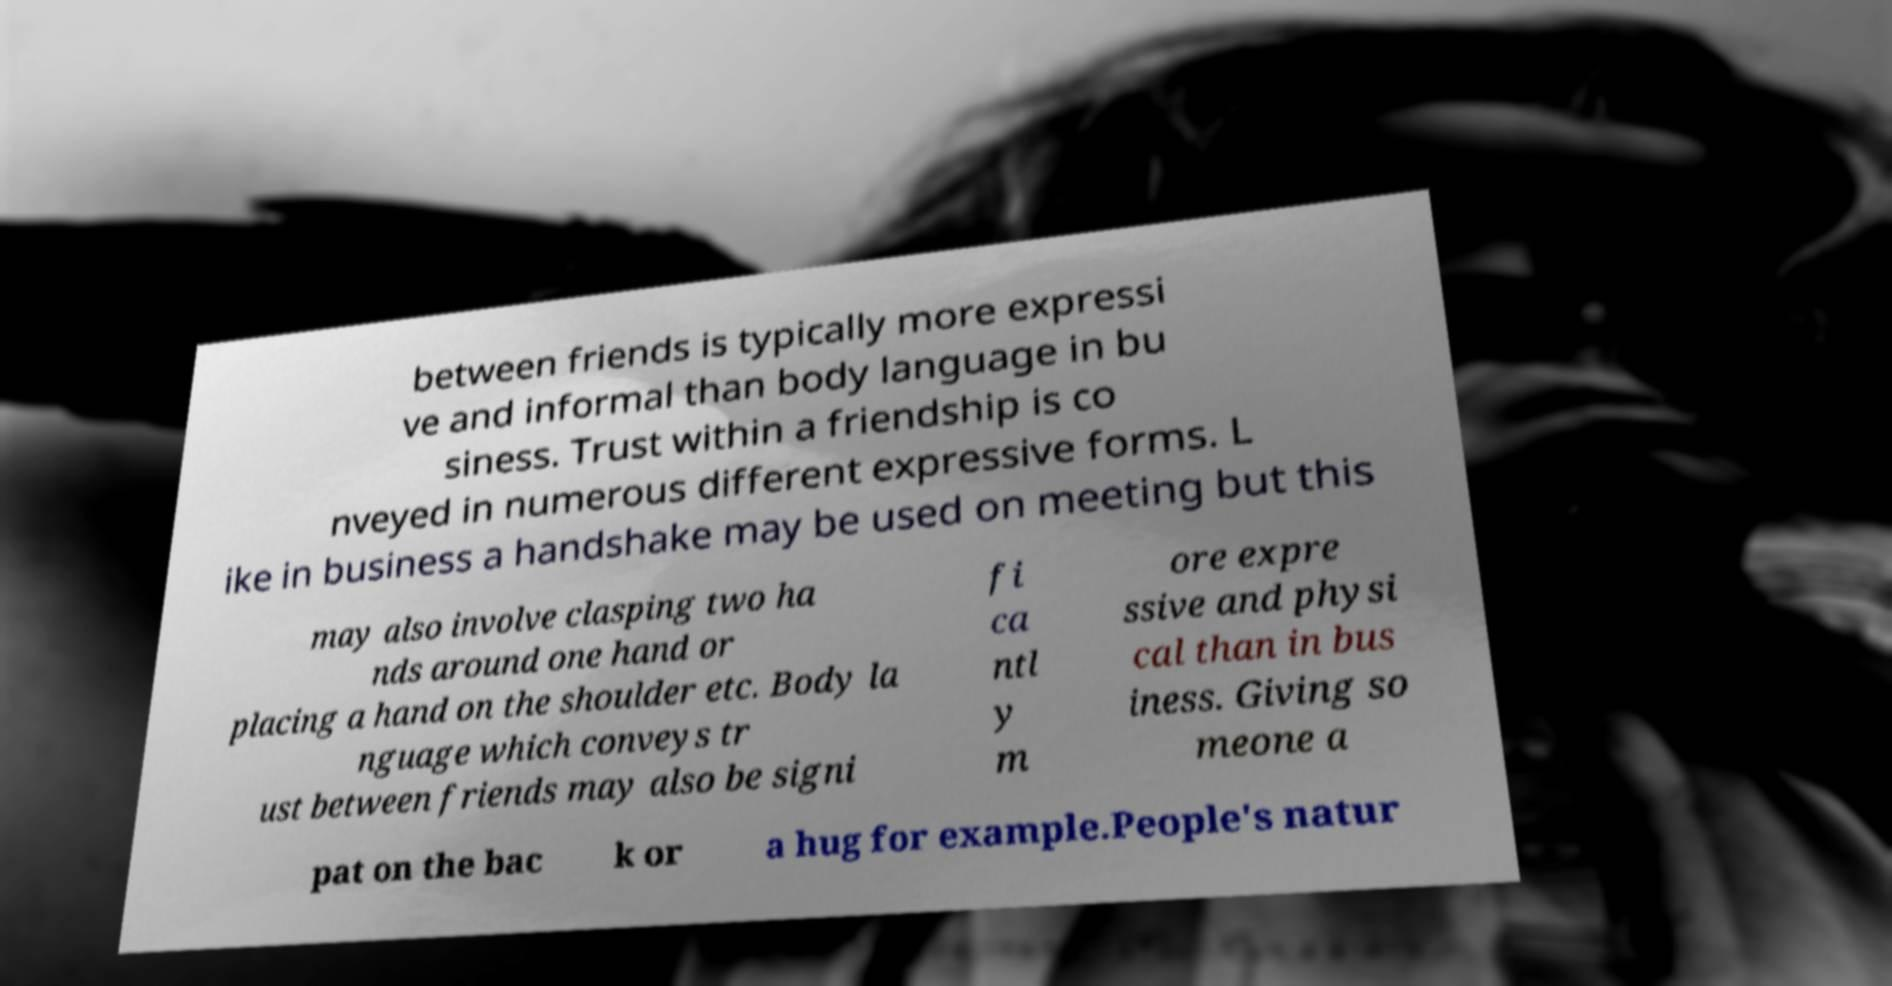Can you accurately transcribe the text from the provided image for me? between friends is typically more expressi ve and informal than body language in bu siness. Trust within a friendship is co nveyed in numerous different expressive forms. L ike in business a handshake may be used on meeting but this may also involve clasping two ha nds around one hand or placing a hand on the shoulder etc. Body la nguage which conveys tr ust between friends may also be signi fi ca ntl y m ore expre ssive and physi cal than in bus iness. Giving so meone a pat on the bac k or a hug for example.People's natur 